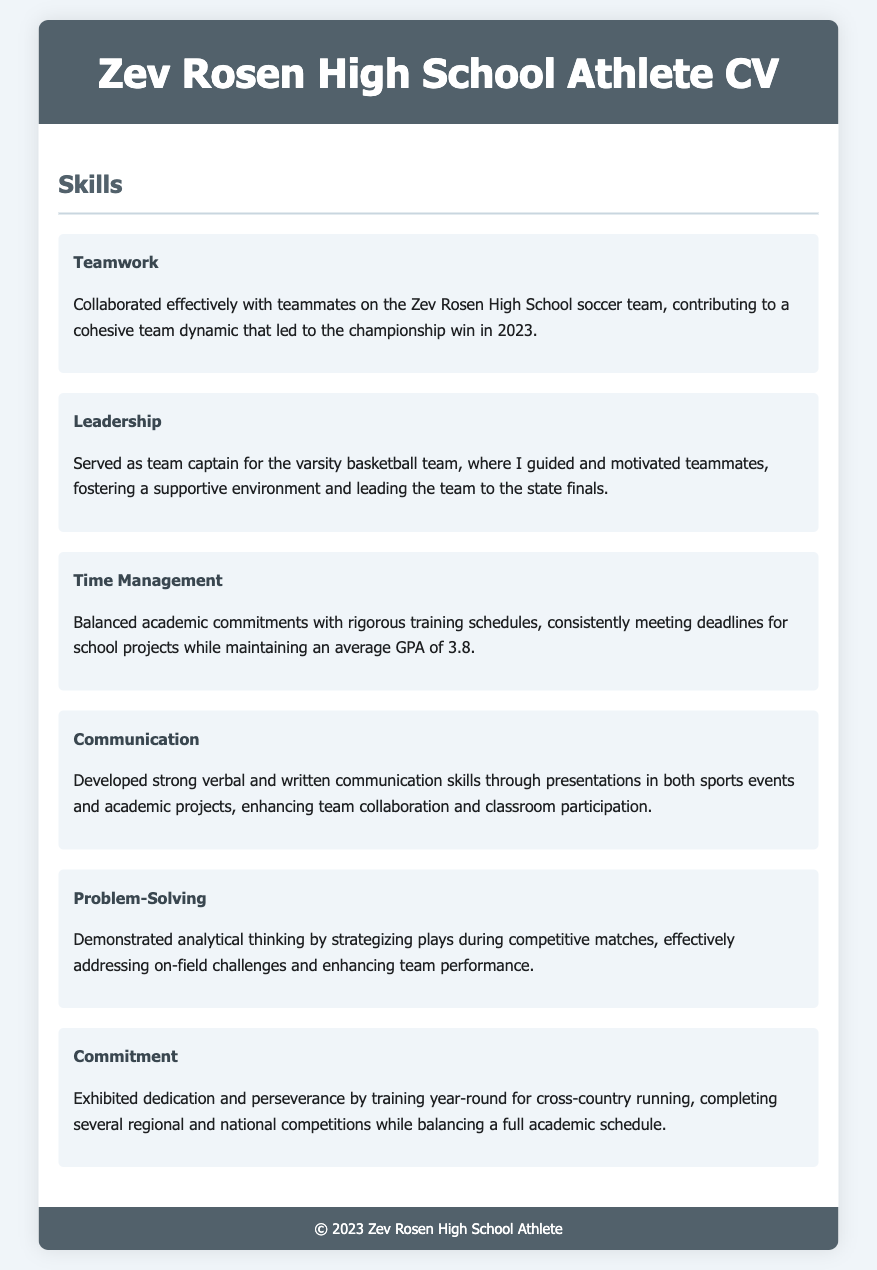What sport did Zev play for the championship win? The document mentions that Zev collaborated effectively with teammates on the soccer team, leading to a championship.
Answer: Soccer What significant role did Zev hold in the varsity basketball team? The document states that Zev served as team captain, guiding and motivating his teammates.
Answer: Team captain What was Zev's average GPA while balancing sports and academics? The CV specifies that Zev maintained an average GPA of 3.8 while managing school and training schedules.
Answer: 3.8 In which year did Zev's soccer team win the championship? The document indicates the championship win for the soccer team occurred in 2023.
Answer: 2023 What quality did Zev demonstrate by completing several regional and national competitions? Zev exhibited dedication and perseverance through year-round training and competition participation.
Answer: Commitment What type of skills did Zev develop through academic projects and sports events? The CV highlights that Zev developed strong verbal and written communication skills.
Answer: Communication What challenge did Zev successfully address during competitive matches? The document states that Zev strategized plays to address on-field challenges, enhancing performance.
Answer: On-field challenges What is the primary focus of the Skills section in the CV? The Skills section highlights various abilities acquired through sports and academics, such as teamwork and leadership.
Answer: Various abilities How did Zev contribute to the team dynamic in soccer? The document notes that Zev collaborated effectively with teammates, contributing to cohesion.
Answer: Cohesion 